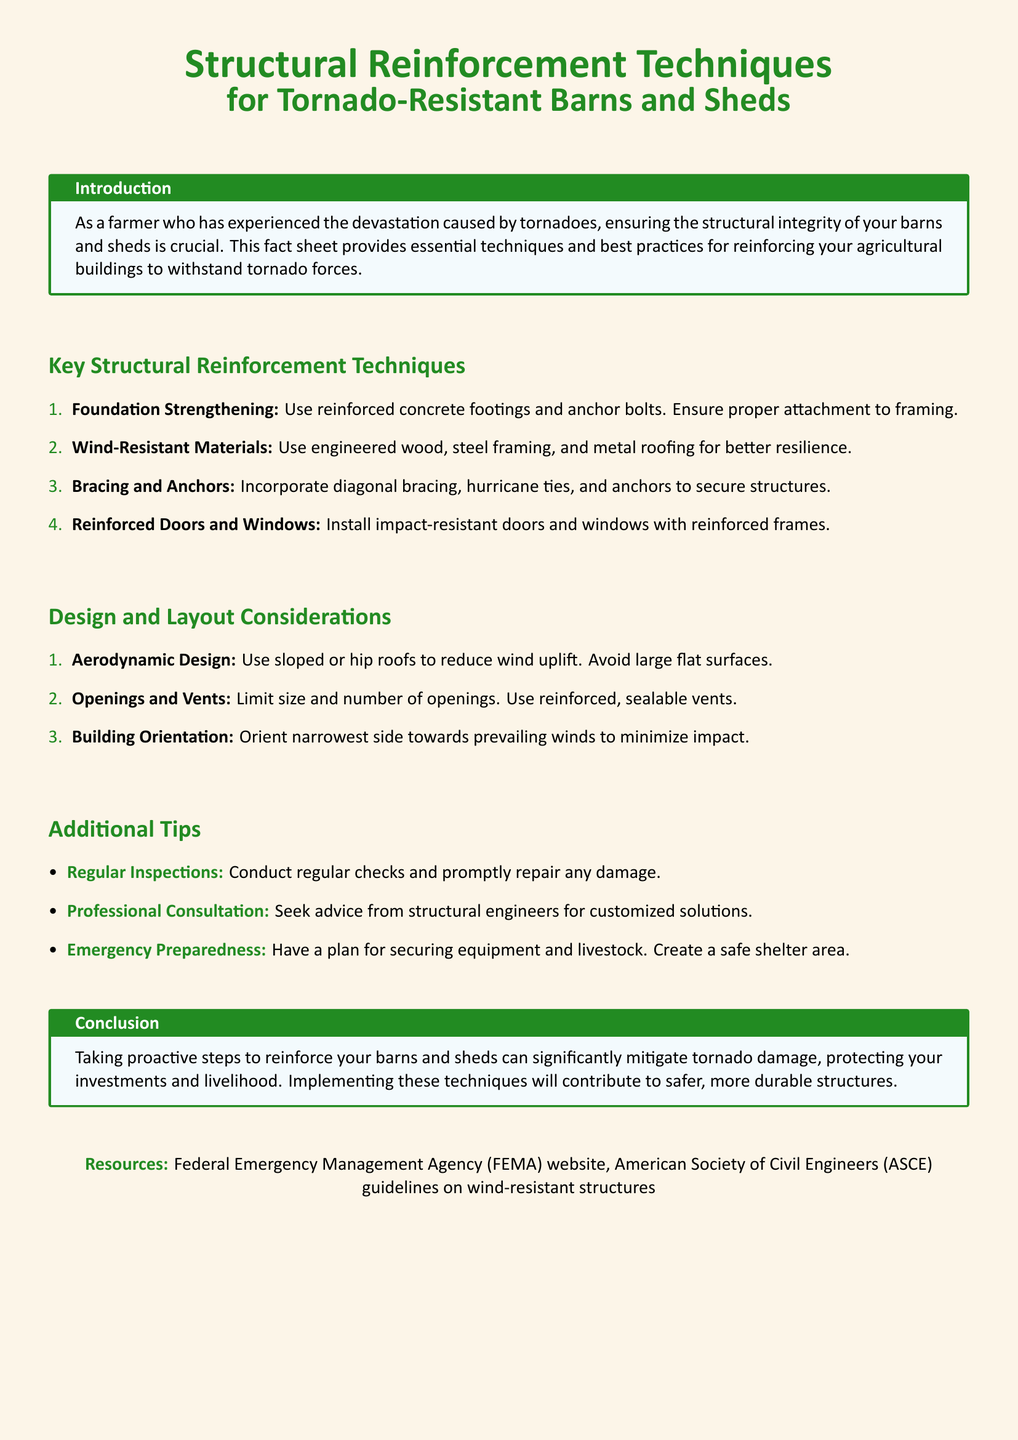What is the purpose of the fact sheet? The fact sheet aims to provide essential techniques and best practices for reinforcing agricultural buildings to withstand tornado forces.
Answer: To provide essential techniques and best practices for reinforcing agricultural buildings What material is recommended for wind resistance? The document recommends using engineered wood, steel framing, and metal roofing for better resilience.
Answer: Engineered wood, steel framing, and metal roofing How many key structural reinforcement techniques are listed? There are four key structural reinforcement techniques listed in the document.
Answer: Four What is one of the design considerations for tornado-resistant buildings? The document suggests using aerodynamic designs such as sloped or hip roofs to reduce wind uplift.
Answer: Aerodynamic design What type of doors should be installed for reinforcement? The recommended doors are impact-resistant with reinforced frames.
Answer: Impact-resistant doors with reinforced frames What is an additional tip for farmers in the document? One of the additional tips includes conducting regular inspections and promptly repairing any damage.
Answer: Regular inspections Which organization is mentioned as a resource? The Federal Emergency Management Agency (FEMA) is mentioned as a resource in the document.
Answer: FEMA What is emphasized regarding building orientation? The document emphasizes orienting the narrowest side towards prevailing winds to minimize impact.
Answer: Orient narrowest side towards prevailing winds 